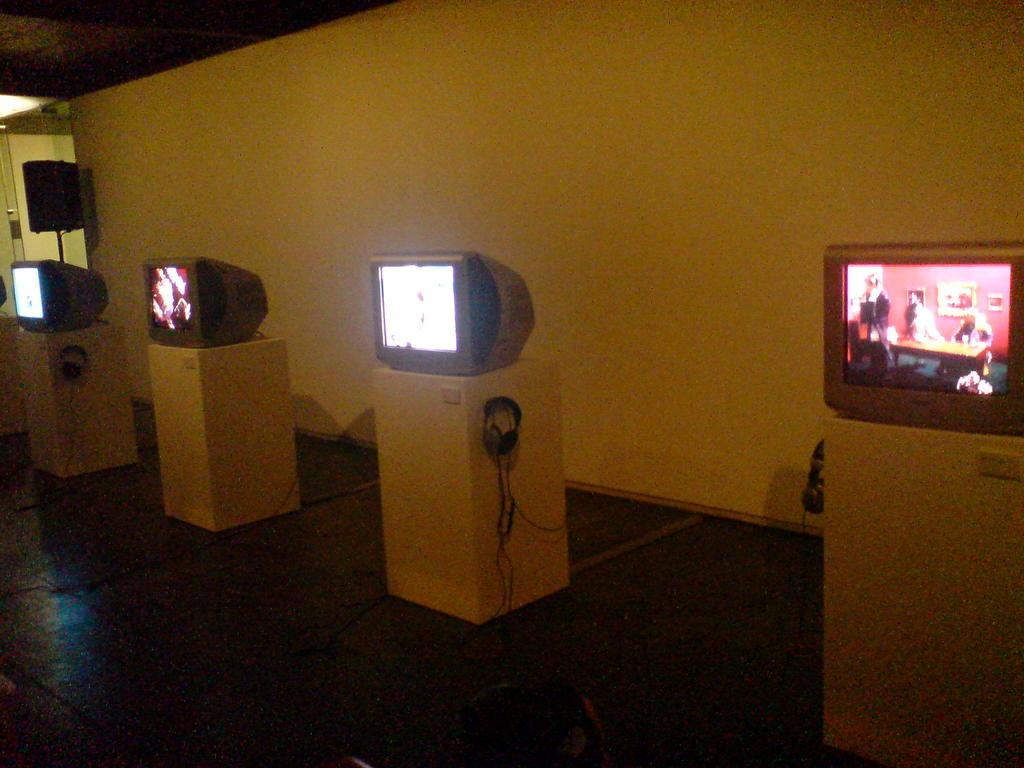Where was the image taken? The image was taken in a room. What electronic devices can be seen in the image? There are televisions in the image. What else is visible in the image besides the televisions? There are cables, a speaker, and a door on the left side of the image. What color is the wall in the background of the image? The wall in the background of the image is painted white. What type of underwear is hanging on the door in the image? There is no underwear present in the image; it only features televisions, cables, a speaker, and a door. 